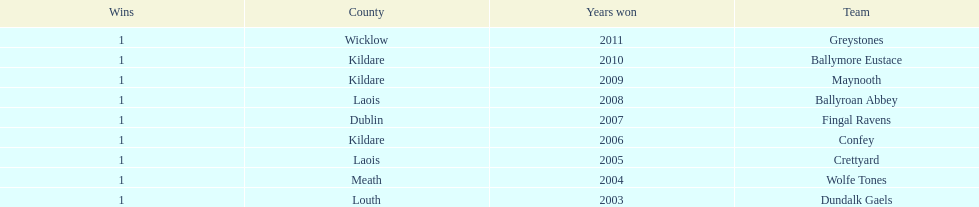How many wins did confey have? 1. 